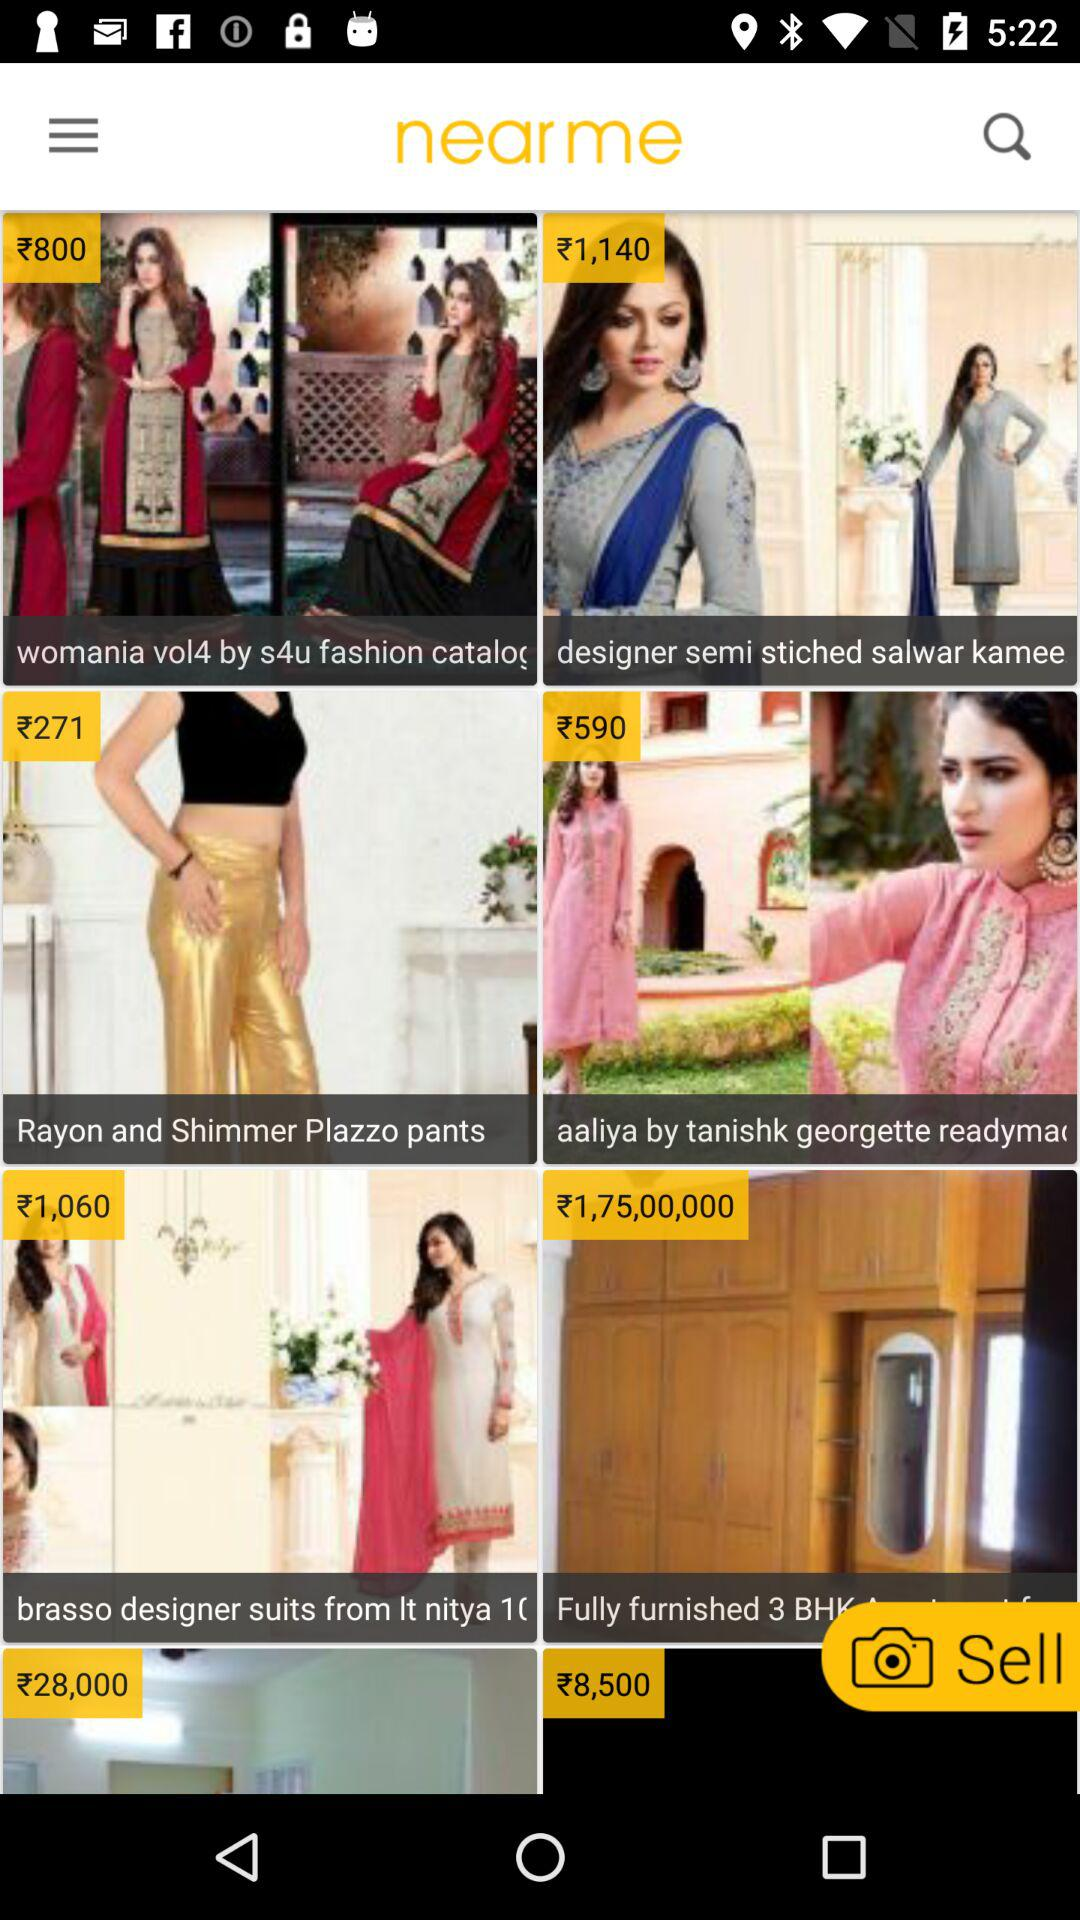How much is the price of "womania vol4 by s4u fashion catalog"? The price is ₹800. 